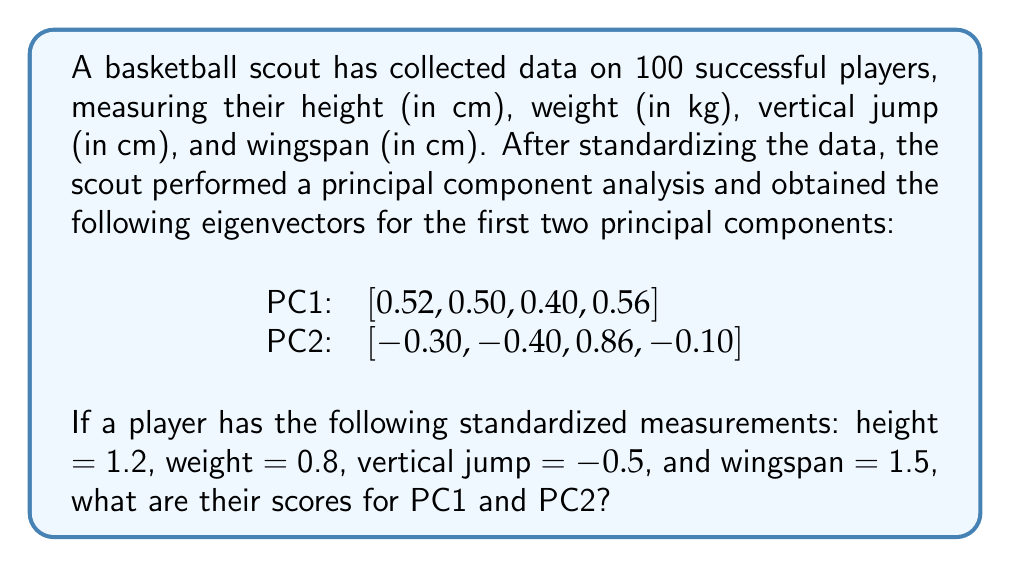Provide a solution to this math problem. To solve this problem, we need to follow these steps:

1. Understand the given data:
   - We have eigenvectors for PC1 and PC2
   - We have standardized measurements for a player

2. Calculate the PC scores using the dot product of the eigenvector and the player's standardized measurements.

For PC1:
$$ \text{PC1 score} = (0.52 \times 1.2) + (0.50 \times 0.8) + (0.40 \times -0.5) + (0.56 \times 1.5) $$
$$ = 0.624 + 0.400 - 0.200 + 0.840 $$
$$ = 1.664 $$

For PC2:
$$ \text{PC2 score} = (-0.30 \times 1.2) + (-0.40 \times 0.8) + (0.86 \times -0.5) + (-0.10 \times 1.5) $$
$$ = -0.360 - 0.320 - 0.430 - 0.150 $$
$$ = -1.260 $$

3. Round the results to three decimal places for precision.
Answer: PC1 score: 1.664
PC2 score: -1.260 